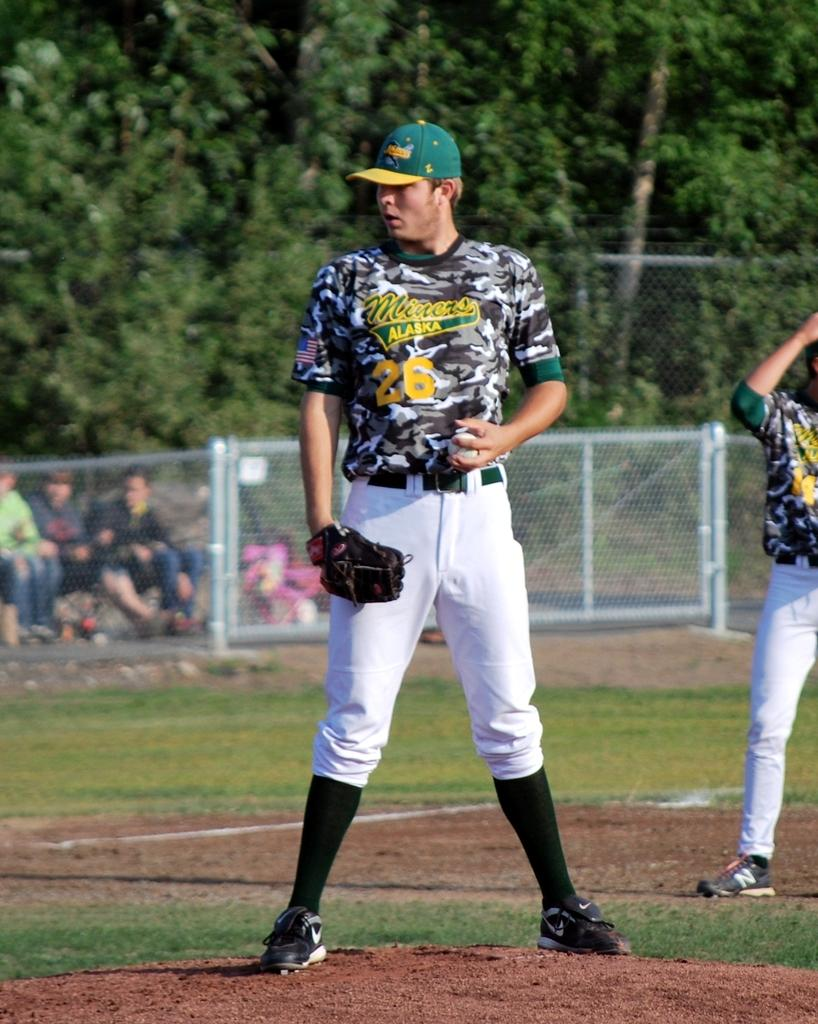<image>
Present a compact description of the photo's key features. Alaska Miners is the name displayed on the pitcher's jersey. 